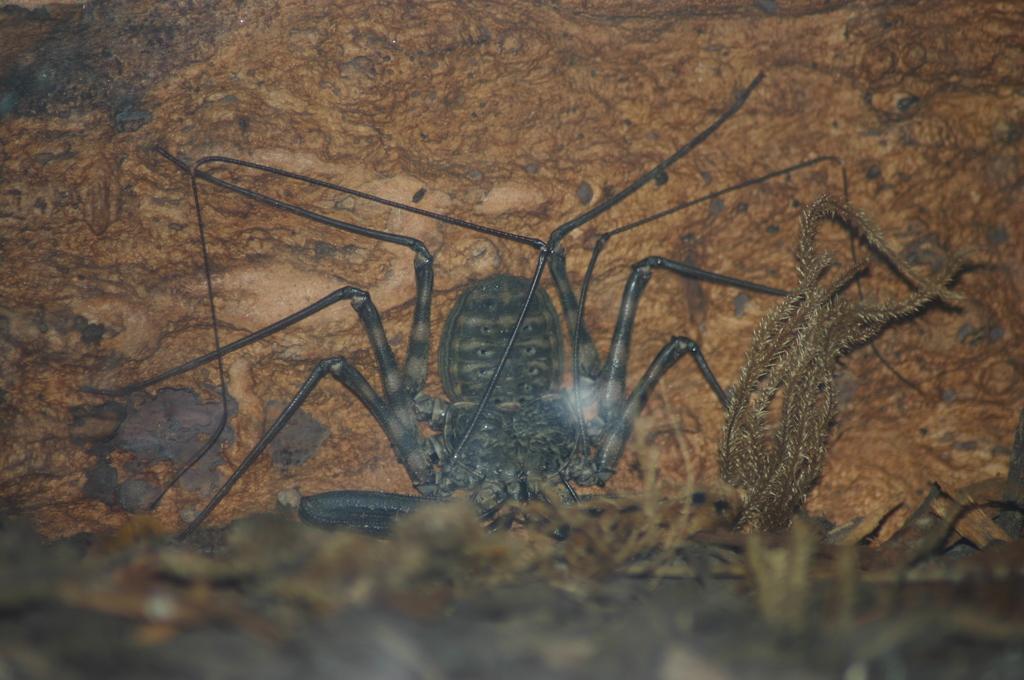In one or two sentences, can you explain what this image depicts? In this image I can see an insect on the ground. I can see few leaves. 